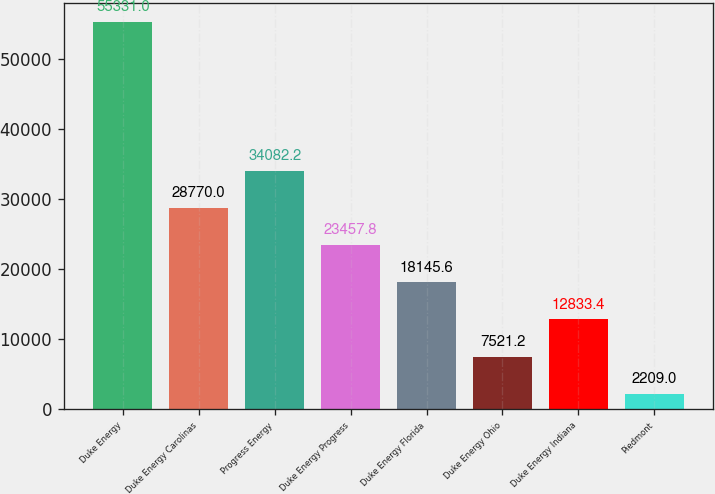Convert chart. <chart><loc_0><loc_0><loc_500><loc_500><bar_chart><fcel>Duke Energy<fcel>Duke Energy Carolinas<fcel>Progress Energy<fcel>Duke Energy Progress<fcel>Duke Energy Florida<fcel>Duke Energy Ohio<fcel>Duke Energy Indiana<fcel>Piedmont<nl><fcel>55331<fcel>28770<fcel>34082.2<fcel>23457.8<fcel>18145.6<fcel>7521.2<fcel>12833.4<fcel>2209<nl></chart> 